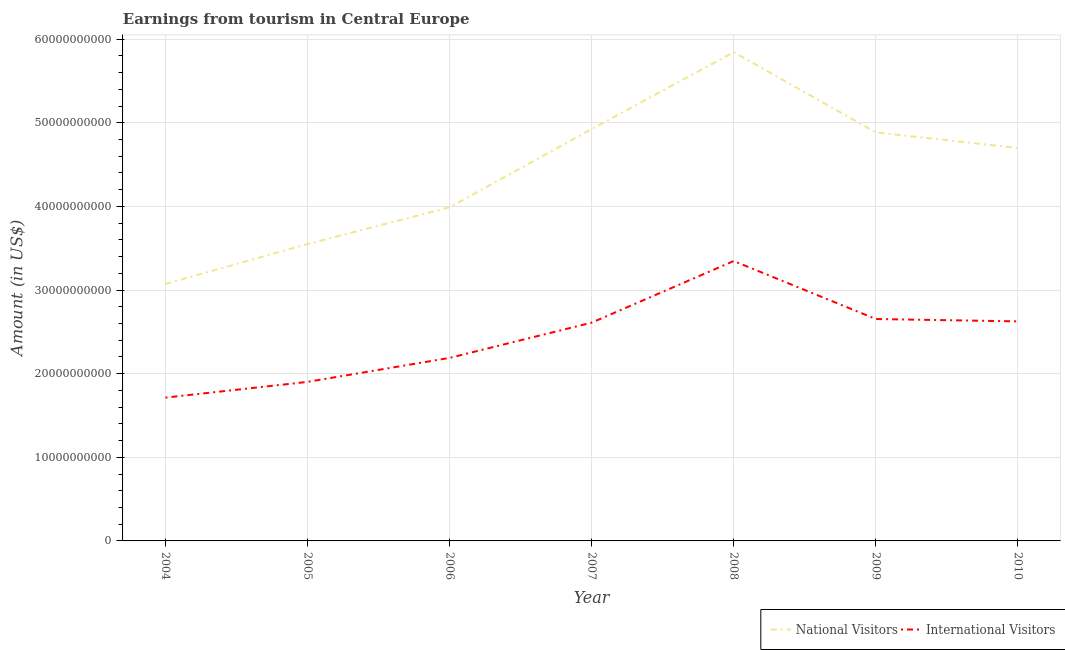Is the number of lines equal to the number of legend labels?
Ensure brevity in your answer.  Yes. What is the amount earned from international visitors in 2010?
Give a very brief answer. 2.63e+1. Across all years, what is the maximum amount earned from national visitors?
Provide a succinct answer. 5.84e+1. Across all years, what is the minimum amount earned from international visitors?
Your response must be concise. 1.71e+1. In which year was the amount earned from international visitors minimum?
Keep it short and to the point. 2004. What is the total amount earned from national visitors in the graph?
Provide a short and direct response. 3.10e+11. What is the difference between the amount earned from international visitors in 2005 and that in 2007?
Your answer should be compact. -7.09e+09. What is the difference between the amount earned from international visitors in 2004 and the amount earned from national visitors in 2005?
Provide a succinct answer. -1.84e+1. What is the average amount earned from international visitors per year?
Offer a very short reply. 2.43e+1. In the year 2006, what is the difference between the amount earned from international visitors and amount earned from national visitors?
Offer a terse response. -1.80e+1. What is the ratio of the amount earned from national visitors in 2006 to that in 2008?
Your answer should be very brief. 0.68. Is the difference between the amount earned from international visitors in 2008 and 2009 greater than the difference between the amount earned from national visitors in 2008 and 2009?
Ensure brevity in your answer.  No. What is the difference between the highest and the second highest amount earned from national visitors?
Offer a very short reply. 9.20e+09. What is the difference between the highest and the lowest amount earned from international visitors?
Provide a succinct answer. 1.63e+1. Where does the legend appear in the graph?
Offer a terse response. Bottom right. What is the title of the graph?
Offer a very short reply. Earnings from tourism in Central Europe. What is the label or title of the Y-axis?
Your response must be concise. Amount (in US$). What is the Amount (in US$) in National Visitors in 2004?
Offer a terse response. 3.07e+1. What is the Amount (in US$) of International Visitors in 2004?
Your answer should be compact. 1.71e+1. What is the Amount (in US$) in National Visitors in 2005?
Offer a very short reply. 3.55e+1. What is the Amount (in US$) in International Visitors in 2005?
Your response must be concise. 1.90e+1. What is the Amount (in US$) in National Visitors in 2006?
Your answer should be very brief. 3.99e+1. What is the Amount (in US$) in International Visitors in 2006?
Keep it short and to the point. 2.19e+1. What is the Amount (in US$) of National Visitors in 2007?
Provide a short and direct response. 4.92e+1. What is the Amount (in US$) in International Visitors in 2007?
Offer a terse response. 2.61e+1. What is the Amount (in US$) of National Visitors in 2008?
Give a very brief answer. 5.84e+1. What is the Amount (in US$) of International Visitors in 2008?
Provide a short and direct response. 3.35e+1. What is the Amount (in US$) in National Visitors in 2009?
Your answer should be compact. 4.89e+1. What is the Amount (in US$) in International Visitors in 2009?
Make the answer very short. 2.65e+1. What is the Amount (in US$) of National Visitors in 2010?
Your answer should be very brief. 4.70e+1. What is the Amount (in US$) in International Visitors in 2010?
Offer a terse response. 2.63e+1. Across all years, what is the maximum Amount (in US$) in National Visitors?
Your response must be concise. 5.84e+1. Across all years, what is the maximum Amount (in US$) of International Visitors?
Offer a very short reply. 3.35e+1. Across all years, what is the minimum Amount (in US$) in National Visitors?
Give a very brief answer. 3.07e+1. Across all years, what is the minimum Amount (in US$) in International Visitors?
Provide a succinct answer. 1.71e+1. What is the total Amount (in US$) in National Visitors in the graph?
Your answer should be compact. 3.10e+11. What is the total Amount (in US$) in International Visitors in the graph?
Provide a short and direct response. 1.70e+11. What is the difference between the Amount (in US$) in National Visitors in 2004 and that in 2005?
Give a very brief answer. -4.77e+09. What is the difference between the Amount (in US$) of International Visitors in 2004 and that in 2005?
Provide a succinct answer. -1.88e+09. What is the difference between the Amount (in US$) of National Visitors in 2004 and that in 2006?
Your response must be concise. -9.17e+09. What is the difference between the Amount (in US$) of International Visitors in 2004 and that in 2006?
Provide a succinct answer. -4.75e+09. What is the difference between the Amount (in US$) in National Visitors in 2004 and that in 2007?
Offer a terse response. -1.85e+1. What is the difference between the Amount (in US$) in International Visitors in 2004 and that in 2007?
Make the answer very short. -8.97e+09. What is the difference between the Amount (in US$) in National Visitors in 2004 and that in 2008?
Offer a terse response. -2.77e+1. What is the difference between the Amount (in US$) of International Visitors in 2004 and that in 2008?
Give a very brief answer. -1.63e+1. What is the difference between the Amount (in US$) of National Visitors in 2004 and that in 2009?
Ensure brevity in your answer.  -1.81e+1. What is the difference between the Amount (in US$) in International Visitors in 2004 and that in 2009?
Provide a short and direct response. -9.40e+09. What is the difference between the Amount (in US$) of National Visitors in 2004 and that in 2010?
Provide a short and direct response. -1.63e+1. What is the difference between the Amount (in US$) of International Visitors in 2004 and that in 2010?
Offer a terse response. -9.12e+09. What is the difference between the Amount (in US$) of National Visitors in 2005 and that in 2006?
Ensure brevity in your answer.  -4.40e+09. What is the difference between the Amount (in US$) of International Visitors in 2005 and that in 2006?
Provide a succinct answer. -2.87e+09. What is the difference between the Amount (in US$) of National Visitors in 2005 and that in 2007?
Offer a terse response. -1.38e+1. What is the difference between the Amount (in US$) in International Visitors in 2005 and that in 2007?
Your response must be concise. -7.09e+09. What is the difference between the Amount (in US$) of National Visitors in 2005 and that in 2008?
Provide a short and direct response. -2.30e+1. What is the difference between the Amount (in US$) in International Visitors in 2005 and that in 2008?
Give a very brief answer. -1.45e+1. What is the difference between the Amount (in US$) in National Visitors in 2005 and that in 2009?
Ensure brevity in your answer.  -1.34e+1. What is the difference between the Amount (in US$) of International Visitors in 2005 and that in 2009?
Ensure brevity in your answer.  -7.52e+09. What is the difference between the Amount (in US$) in National Visitors in 2005 and that in 2010?
Your answer should be compact. -1.15e+1. What is the difference between the Amount (in US$) in International Visitors in 2005 and that in 2010?
Give a very brief answer. -7.24e+09. What is the difference between the Amount (in US$) of National Visitors in 2006 and that in 2007?
Offer a very short reply. -9.35e+09. What is the difference between the Amount (in US$) in International Visitors in 2006 and that in 2007?
Ensure brevity in your answer.  -4.22e+09. What is the difference between the Amount (in US$) in National Visitors in 2006 and that in 2008?
Keep it short and to the point. -1.86e+1. What is the difference between the Amount (in US$) in International Visitors in 2006 and that in 2008?
Provide a succinct answer. -1.16e+1. What is the difference between the Amount (in US$) in National Visitors in 2006 and that in 2009?
Keep it short and to the point. -8.96e+09. What is the difference between the Amount (in US$) of International Visitors in 2006 and that in 2009?
Offer a very short reply. -4.65e+09. What is the difference between the Amount (in US$) in National Visitors in 2006 and that in 2010?
Keep it short and to the point. -7.08e+09. What is the difference between the Amount (in US$) in International Visitors in 2006 and that in 2010?
Offer a terse response. -4.36e+09. What is the difference between the Amount (in US$) of National Visitors in 2007 and that in 2008?
Ensure brevity in your answer.  -9.20e+09. What is the difference between the Amount (in US$) in International Visitors in 2007 and that in 2008?
Offer a very short reply. -7.37e+09. What is the difference between the Amount (in US$) of National Visitors in 2007 and that in 2009?
Offer a very short reply. 3.95e+08. What is the difference between the Amount (in US$) in International Visitors in 2007 and that in 2009?
Your response must be concise. -4.35e+08. What is the difference between the Amount (in US$) in National Visitors in 2007 and that in 2010?
Give a very brief answer. 2.27e+09. What is the difference between the Amount (in US$) of International Visitors in 2007 and that in 2010?
Offer a very short reply. -1.49e+08. What is the difference between the Amount (in US$) of National Visitors in 2008 and that in 2009?
Offer a very short reply. 9.60e+09. What is the difference between the Amount (in US$) of International Visitors in 2008 and that in 2009?
Provide a short and direct response. 6.93e+09. What is the difference between the Amount (in US$) of National Visitors in 2008 and that in 2010?
Provide a short and direct response. 1.15e+1. What is the difference between the Amount (in US$) in International Visitors in 2008 and that in 2010?
Give a very brief answer. 7.22e+09. What is the difference between the Amount (in US$) in National Visitors in 2009 and that in 2010?
Your response must be concise. 1.87e+09. What is the difference between the Amount (in US$) of International Visitors in 2009 and that in 2010?
Your answer should be very brief. 2.86e+08. What is the difference between the Amount (in US$) in National Visitors in 2004 and the Amount (in US$) in International Visitors in 2005?
Provide a succinct answer. 1.17e+1. What is the difference between the Amount (in US$) of National Visitors in 2004 and the Amount (in US$) of International Visitors in 2006?
Offer a very short reply. 8.84e+09. What is the difference between the Amount (in US$) of National Visitors in 2004 and the Amount (in US$) of International Visitors in 2007?
Your response must be concise. 4.63e+09. What is the difference between the Amount (in US$) of National Visitors in 2004 and the Amount (in US$) of International Visitors in 2008?
Provide a short and direct response. -2.74e+09. What is the difference between the Amount (in US$) in National Visitors in 2004 and the Amount (in US$) in International Visitors in 2009?
Your answer should be very brief. 4.19e+09. What is the difference between the Amount (in US$) in National Visitors in 2004 and the Amount (in US$) in International Visitors in 2010?
Your response must be concise. 4.48e+09. What is the difference between the Amount (in US$) in National Visitors in 2005 and the Amount (in US$) in International Visitors in 2006?
Provide a short and direct response. 1.36e+1. What is the difference between the Amount (in US$) of National Visitors in 2005 and the Amount (in US$) of International Visitors in 2007?
Provide a succinct answer. 9.40e+09. What is the difference between the Amount (in US$) in National Visitors in 2005 and the Amount (in US$) in International Visitors in 2008?
Keep it short and to the point. 2.03e+09. What is the difference between the Amount (in US$) in National Visitors in 2005 and the Amount (in US$) in International Visitors in 2009?
Ensure brevity in your answer.  8.96e+09. What is the difference between the Amount (in US$) in National Visitors in 2005 and the Amount (in US$) in International Visitors in 2010?
Provide a short and direct response. 9.25e+09. What is the difference between the Amount (in US$) in National Visitors in 2006 and the Amount (in US$) in International Visitors in 2007?
Your answer should be very brief. 1.38e+1. What is the difference between the Amount (in US$) in National Visitors in 2006 and the Amount (in US$) in International Visitors in 2008?
Your answer should be compact. 6.43e+09. What is the difference between the Amount (in US$) of National Visitors in 2006 and the Amount (in US$) of International Visitors in 2009?
Your response must be concise. 1.34e+1. What is the difference between the Amount (in US$) of National Visitors in 2006 and the Amount (in US$) of International Visitors in 2010?
Ensure brevity in your answer.  1.36e+1. What is the difference between the Amount (in US$) in National Visitors in 2007 and the Amount (in US$) in International Visitors in 2008?
Make the answer very short. 1.58e+1. What is the difference between the Amount (in US$) in National Visitors in 2007 and the Amount (in US$) in International Visitors in 2009?
Offer a terse response. 2.27e+1. What is the difference between the Amount (in US$) of National Visitors in 2007 and the Amount (in US$) of International Visitors in 2010?
Provide a succinct answer. 2.30e+1. What is the difference between the Amount (in US$) of National Visitors in 2008 and the Amount (in US$) of International Visitors in 2009?
Provide a short and direct response. 3.19e+1. What is the difference between the Amount (in US$) of National Visitors in 2008 and the Amount (in US$) of International Visitors in 2010?
Offer a very short reply. 3.22e+1. What is the difference between the Amount (in US$) in National Visitors in 2009 and the Amount (in US$) in International Visitors in 2010?
Keep it short and to the point. 2.26e+1. What is the average Amount (in US$) in National Visitors per year?
Offer a terse response. 4.42e+1. What is the average Amount (in US$) of International Visitors per year?
Give a very brief answer. 2.43e+1. In the year 2004, what is the difference between the Amount (in US$) of National Visitors and Amount (in US$) of International Visitors?
Offer a very short reply. 1.36e+1. In the year 2005, what is the difference between the Amount (in US$) in National Visitors and Amount (in US$) in International Visitors?
Your response must be concise. 1.65e+1. In the year 2006, what is the difference between the Amount (in US$) of National Visitors and Amount (in US$) of International Visitors?
Give a very brief answer. 1.80e+1. In the year 2007, what is the difference between the Amount (in US$) of National Visitors and Amount (in US$) of International Visitors?
Offer a very short reply. 2.31e+1. In the year 2008, what is the difference between the Amount (in US$) in National Visitors and Amount (in US$) in International Visitors?
Keep it short and to the point. 2.50e+1. In the year 2009, what is the difference between the Amount (in US$) of National Visitors and Amount (in US$) of International Visitors?
Your answer should be compact. 2.23e+1. In the year 2010, what is the difference between the Amount (in US$) of National Visitors and Amount (in US$) of International Visitors?
Your answer should be very brief. 2.07e+1. What is the ratio of the Amount (in US$) in National Visitors in 2004 to that in 2005?
Your response must be concise. 0.87. What is the ratio of the Amount (in US$) in International Visitors in 2004 to that in 2005?
Offer a very short reply. 0.9. What is the ratio of the Amount (in US$) of National Visitors in 2004 to that in 2006?
Offer a very short reply. 0.77. What is the ratio of the Amount (in US$) in International Visitors in 2004 to that in 2006?
Keep it short and to the point. 0.78. What is the ratio of the Amount (in US$) of National Visitors in 2004 to that in 2007?
Ensure brevity in your answer.  0.62. What is the ratio of the Amount (in US$) in International Visitors in 2004 to that in 2007?
Offer a very short reply. 0.66. What is the ratio of the Amount (in US$) of National Visitors in 2004 to that in 2008?
Your answer should be very brief. 0.53. What is the ratio of the Amount (in US$) of International Visitors in 2004 to that in 2008?
Offer a terse response. 0.51. What is the ratio of the Amount (in US$) of National Visitors in 2004 to that in 2009?
Your response must be concise. 0.63. What is the ratio of the Amount (in US$) of International Visitors in 2004 to that in 2009?
Make the answer very short. 0.65. What is the ratio of the Amount (in US$) of National Visitors in 2004 to that in 2010?
Give a very brief answer. 0.65. What is the ratio of the Amount (in US$) in International Visitors in 2004 to that in 2010?
Your answer should be very brief. 0.65. What is the ratio of the Amount (in US$) of National Visitors in 2005 to that in 2006?
Ensure brevity in your answer.  0.89. What is the ratio of the Amount (in US$) in International Visitors in 2005 to that in 2006?
Provide a succinct answer. 0.87. What is the ratio of the Amount (in US$) of National Visitors in 2005 to that in 2007?
Keep it short and to the point. 0.72. What is the ratio of the Amount (in US$) in International Visitors in 2005 to that in 2007?
Your answer should be very brief. 0.73. What is the ratio of the Amount (in US$) in National Visitors in 2005 to that in 2008?
Provide a short and direct response. 0.61. What is the ratio of the Amount (in US$) of International Visitors in 2005 to that in 2008?
Offer a terse response. 0.57. What is the ratio of the Amount (in US$) of National Visitors in 2005 to that in 2009?
Provide a short and direct response. 0.73. What is the ratio of the Amount (in US$) in International Visitors in 2005 to that in 2009?
Provide a short and direct response. 0.72. What is the ratio of the Amount (in US$) of National Visitors in 2005 to that in 2010?
Ensure brevity in your answer.  0.76. What is the ratio of the Amount (in US$) of International Visitors in 2005 to that in 2010?
Your response must be concise. 0.72. What is the ratio of the Amount (in US$) of National Visitors in 2006 to that in 2007?
Provide a short and direct response. 0.81. What is the ratio of the Amount (in US$) in International Visitors in 2006 to that in 2007?
Provide a short and direct response. 0.84. What is the ratio of the Amount (in US$) of National Visitors in 2006 to that in 2008?
Offer a very short reply. 0.68. What is the ratio of the Amount (in US$) of International Visitors in 2006 to that in 2008?
Offer a very short reply. 0.65. What is the ratio of the Amount (in US$) in National Visitors in 2006 to that in 2009?
Provide a succinct answer. 0.82. What is the ratio of the Amount (in US$) in International Visitors in 2006 to that in 2009?
Your response must be concise. 0.82. What is the ratio of the Amount (in US$) of National Visitors in 2006 to that in 2010?
Give a very brief answer. 0.85. What is the ratio of the Amount (in US$) of International Visitors in 2006 to that in 2010?
Provide a short and direct response. 0.83. What is the ratio of the Amount (in US$) in National Visitors in 2007 to that in 2008?
Your response must be concise. 0.84. What is the ratio of the Amount (in US$) in International Visitors in 2007 to that in 2008?
Ensure brevity in your answer.  0.78. What is the ratio of the Amount (in US$) in International Visitors in 2007 to that in 2009?
Make the answer very short. 0.98. What is the ratio of the Amount (in US$) in National Visitors in 2007 to that in 2010?
Offer a terse response. 1.05. What is the ratio of the Amount (in US$) in International Visitors in 2007 to that in 2010?
Your answer should be very brief. 0.99. What is the ratio of the Amount (in US$) of National Visitors in 2008 to that in 2009?
Ensure brevity in your answer.  1.2. What is the ratio of the Amount (in US$) in International Visitors in 2008 to that in 2009?
Your answer should be very brief. 1.26. What is the ratio of the Amount (in US$) of National Visitors in 2008 to that in 2010?
Give a very brief answer. 1.24. What is the ratio of the Amount (in US$) in International Visitors in 2008 to that in 2010?
Offer a terse response. 1.27. What is the ratio of the Amount (in US$) in National Visitors in 2009 to that in 2010?
Offer a very short reply. 1.04. What is the ratio of the Amount (in US$) in International Visitors in 2009 to that in 2010?
Your answer should be compact. 1.01. What is the difference between the highest and the second highest Amount (in US$) of National Visitors?
Your answer should be very brief. 9.20e+09. What is the difference between the highest and the second highest Amount (in US$) in International Visitors?
Offer a very short reply. 6.93e+09. What is the difference between the highest and the lowest Amount (in US$) of National Visitors?
Make the answer very short. 2.77e+1. What is the difference between the highest and the lowest Amount (in US$) in International Visitors?
Keep it short and to the point. 1.63e+1. 